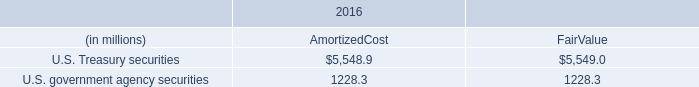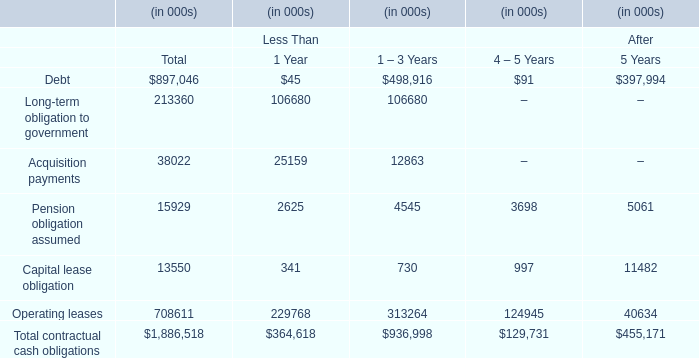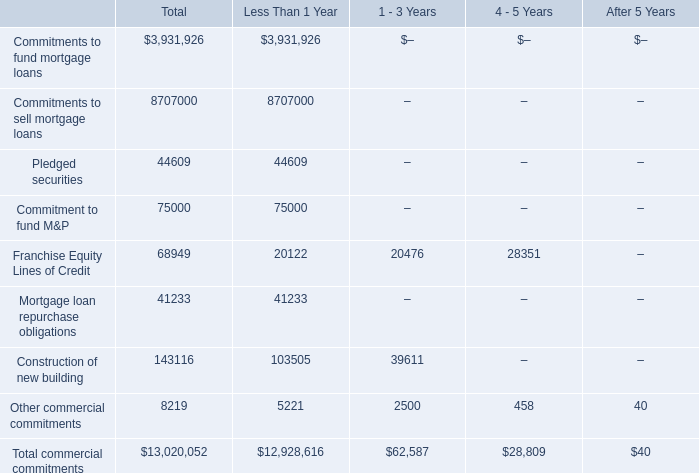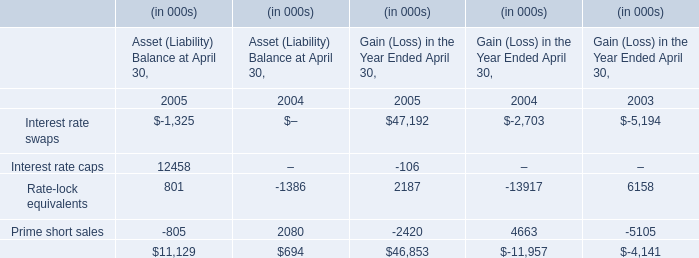what was the average balance within the cash account at the federal reserve bank of chicago for december 31 , 2017 and december 31 , 2016 , in billions? 
Computations: ((34.2 + 6.2) / 2)
Answer: 20.2. 